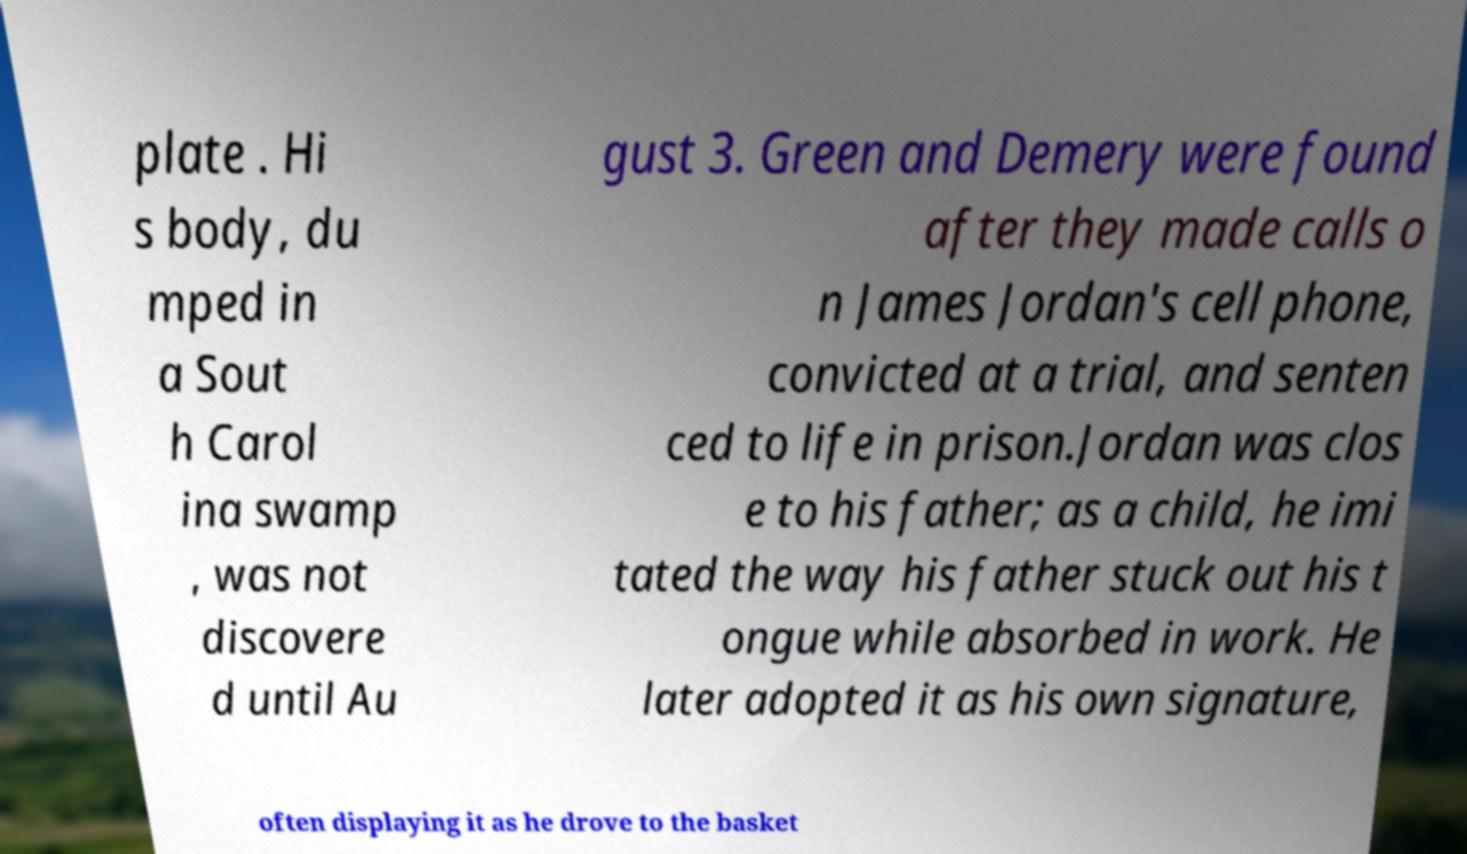Can you read and provide the text displayed in the image?This photo seems to have some interesting text. Can you extract and type it out for me? plate . Hi s body, du mped in a Sout h Carol ina swamp , was not discovere d until Au gust 3. Green and Demery were found after they made calls o n James Jordan's cell phone, convicted at a trial, and senten ced to life in prison.Jordan was clos e to his father; as a child, he imi tated the way his father stuck out his t ongue while absorbed in work. He later adopted it as his own signature, often displaying it as he drove to the basket 